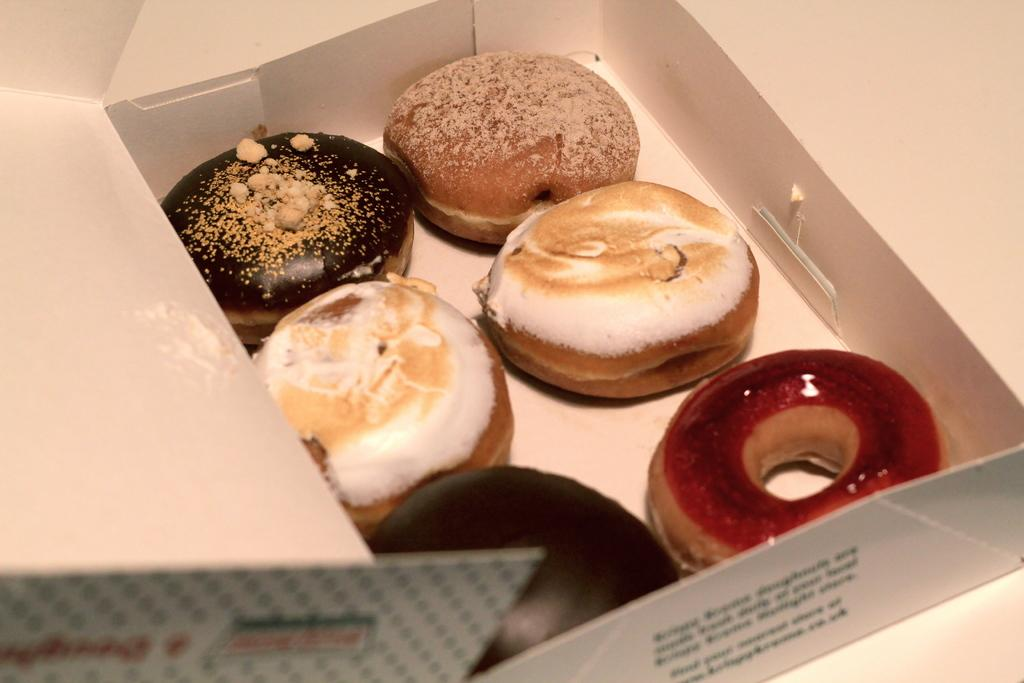What is located in the center of the image? There is a platform in the center of the image. What is on top of the platform? There is a box on the platform. What is inside the box? The box contains doughnuts. Is there any text on the box? Yes, there is text on the box. What type of acoustics can be heard coming from the tree in the image? There is no tree present in the image, so it is not possible to determine the acoustics coming from a tree. 